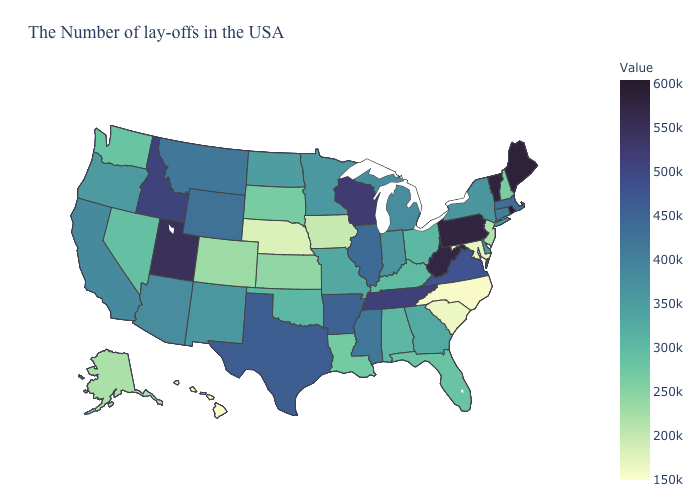Among the states that border Montana , does Wyoming have the highest value?
Concise answer only. No. Does Wisconsin have the highest value in the MidWest?
Write a very short answer. Yes. Does Rhode Island have the highest value in the USA?
Give a very brief answer. Yes. Which states hav the highest value in the South?
Keep it brief. West Virginia. Is the legend a continuous bar?
Quick response, please. Yes. Does South Dakota have a lower value than Vermont?
Write a very short answer. Yes. Which states have the highest value in the USA?
Quick response, please. Rhode Island. Does Wisconsin have the highest value in the MidWest?
Concise answer only. Yes. 